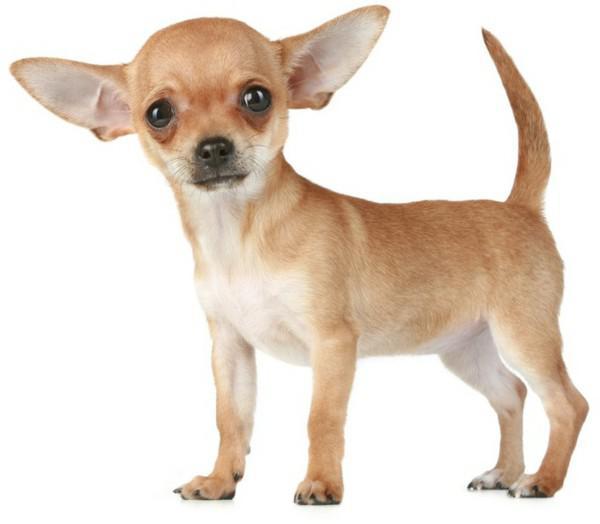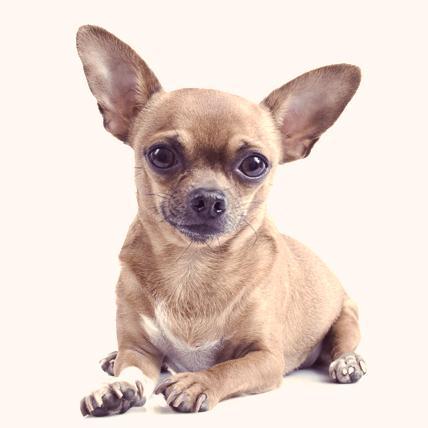The first image is the image on the left, the second image is the image on the right. Considering the images on both sides, is "There is a background in the image to the right." valid? Answer yes or no. No. 